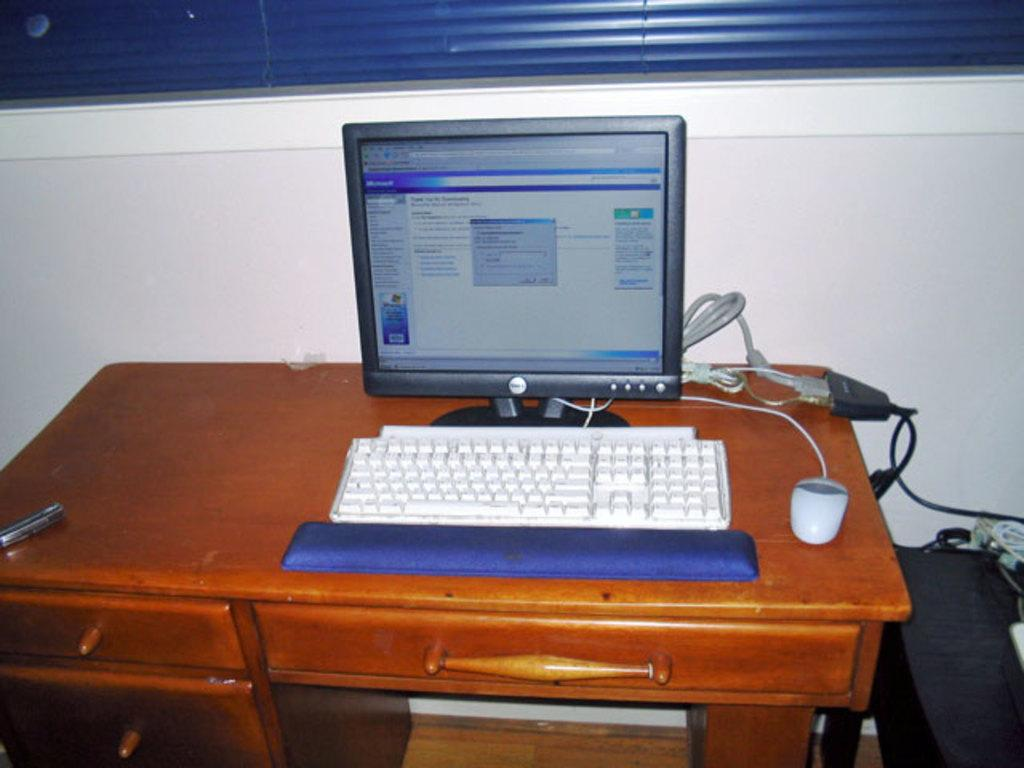What type of furniture is present in the image? There is a desktop in the image. What device is used for typing in the image? There is a keyboard in the image. What device is used for controlling the cursor in the image? There is a mouse in the image. Where are these items located in the image? All these items are on a table. What can be seen in the background of the image? There is a wall visible in the background of the image. What type of hook is hanging on the wall in the image? There is no hook visible on the wall in the image. Is there a battle taking place in the image? There is no battle depicted in the image; it shows a desktop setup with a keyboard, mouse, and wall in the background. 